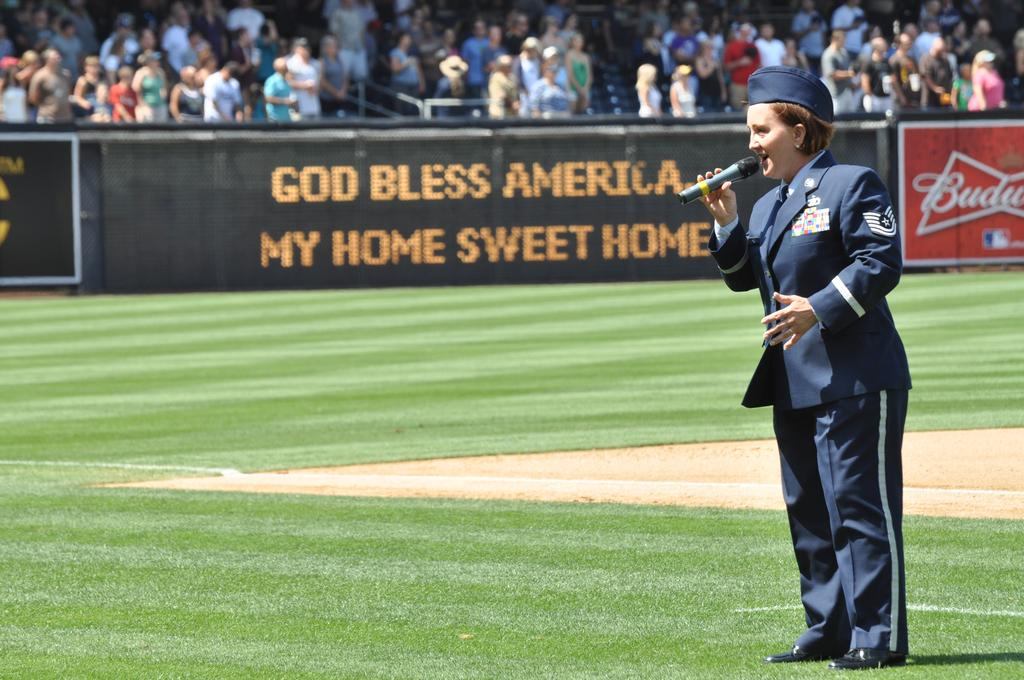<image>
Provide a brief description of the given image. In the center of the baseball field, a female soldier is singing with a sign in front of the stands that says God Bless America, My Home Sweet Home. 